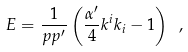<formula> <loc_0><loc_0><loc_500><loc_500>E = \frac { 1 } { p p ^ { \prime } } \left ( \frac { \alpha ^ { \prime } } { 4 } k ^ { i } k _ { i } - 1 \right ) \ ,</formula> 